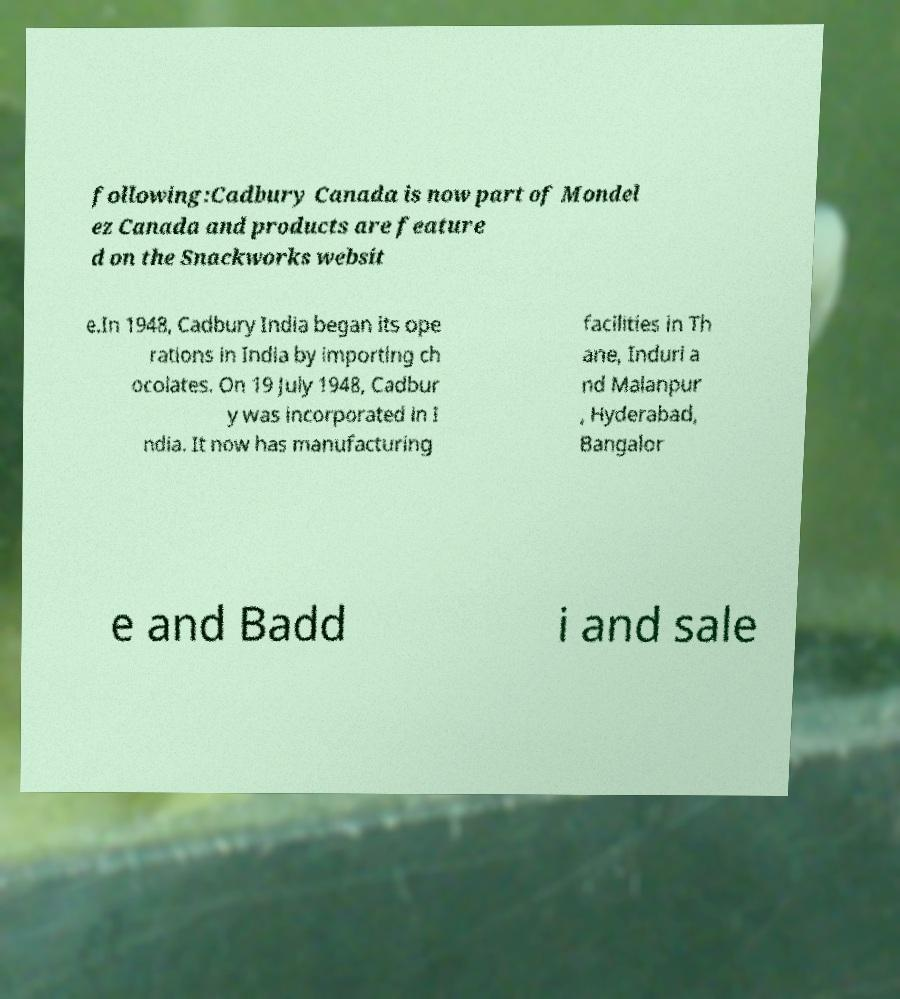Please read and relay the text visible in this image. What does it say? following:Cadbury Canada is now part of Mondel ez Canada and products are feature d on the Snackworks websit e.In 1948, Cadbury India began its ope rations in India by importing ch ocolates. On 19 July 1948, Cadbur y was incorporated in I ndia. It now has manufacturing facilities in Th ane, Induri a nd Malanpur , Hyderabad, Bangalor e and Badd i and sale 